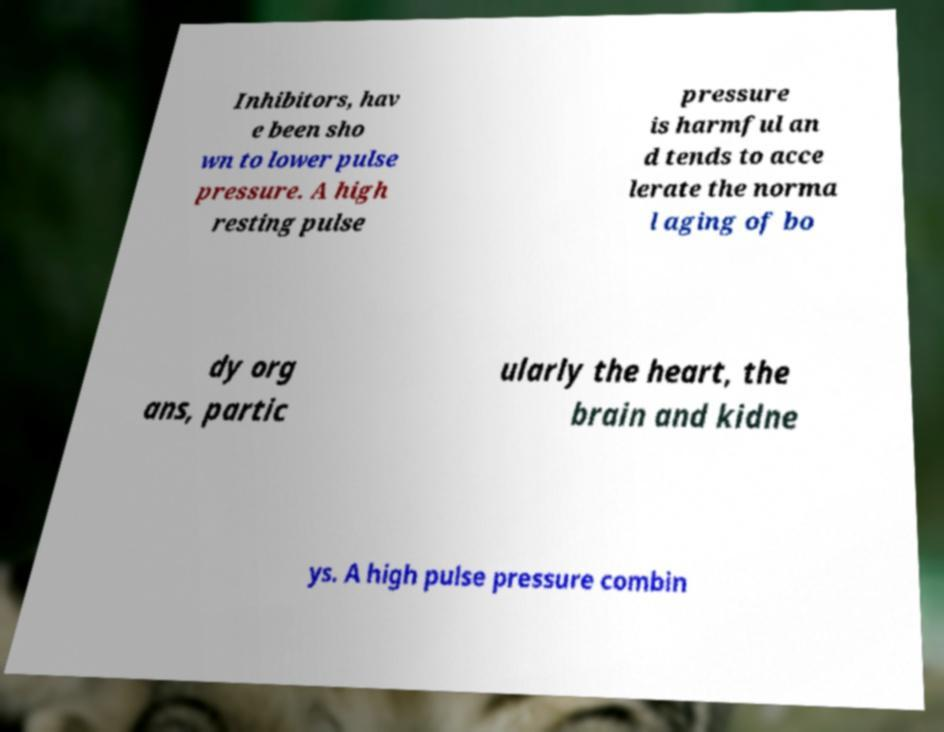What messages or text are displayed in this image? I need them in a readable, typed format. Inhibitors, hav e been sho wn to lower pulse pressure. A high resting pulse pressure is harmful an d tends to acce lerate the norma l aging of bo dy org ans, partic ularly the heart, the brain and kidne ys. A high pulse pressure combin 